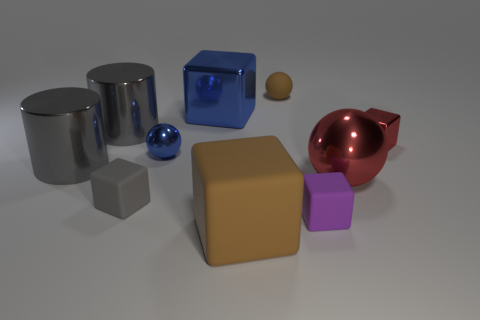Which objects in the image appear to have a reflective surface? The cylindrical objects and the small sphere on the left-hand side of the image have reflective surfaces that catch the light and mirror the environment. How many objects can be seen in the image, and can you describe their colors? There are seven objects in the image: two silver cylinders, a silver sphere, a large blue cube, a red hollow object resembling an apple, a large tan cube, and a small purple cube. 